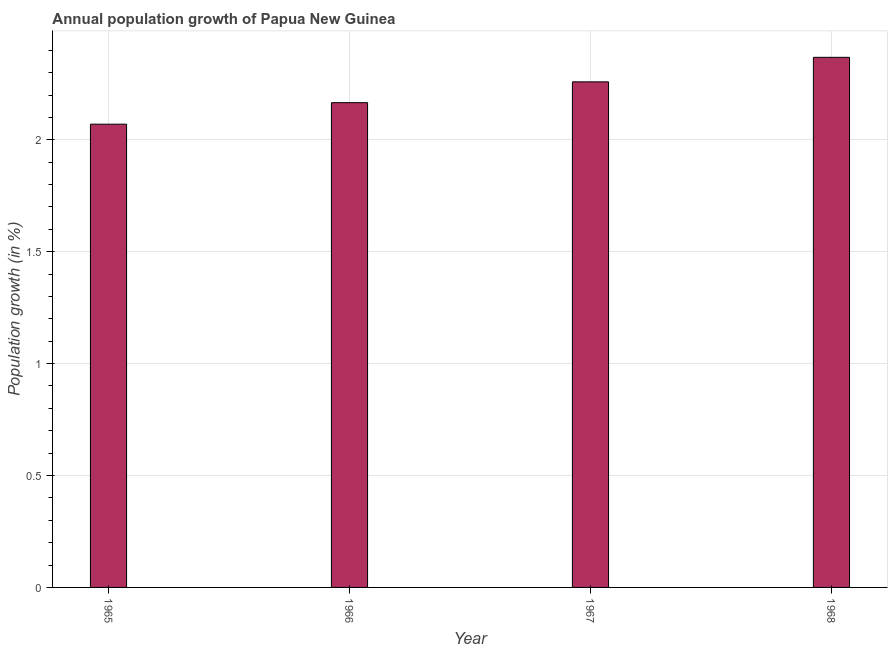Does the graph contain any zero values?
Provide a short and direct response. No. Does the graph contain grids?
Your answer should be very brief. Yes. What is the title of the graph?
Provide a succinct answer. Annual population growth of Papua New Guinea. What is the label or title of the Y-axis?
Offer a terse response. Population growth (in %). What is the population growth in 1968?
Provide a short and direct response. 2.37. Across all years, what is the maximum population growth?
Keep it short and to the point. 2.37. Across all years, what is the minimum population growth?
Ensure brevity in your answer.  2.07. In which year was the population growth maximum?
Provide a short and direct response. 1968. In which year was the population growth minimum?
Provide a succinct answer. 1965. What is the sum of the population growth?
Offer a terse response. 8.86. What is the difference between the population growth in 1965 and 1968?
Provide a short and direct response. -0.3. What is the average population growth per year?
Offer a very short reply. 2.22. What is the median population growth?
Make the answer very short. 2.21. Do a majority of the years between 1966 and 1968 (inclusive) have population growth greater than 2.1 %?
Your answer should be compact. Yes. What is the ratio of the population growth in 1967 to that in 1968?
Your answer should be very brief. 0.95. What is the difference between the highest and the second highest population growth?
Provide a succinct answer. 0.11. Is the sum of the population growth in 1967 and 1968 greater than the maximum population growth across all years?
Your answer should be very brief. Yes. What is the difference between the highest and the lowest population growth?
Keep it short and to the point. 0.3. In how many years, is the population growth greater than the average population growth taken over all years?
Offer a terse response. 2. How many bars are there?
Provide a short and direct response. 4. Are all the bars in the graph horizontal?
Offer a very short reply. No. How many years are there in the graph?
Your answer should be compact. 4. What is the difference between two consecutive major ticks on the Y-axis?
Make the answer very short. 0.5. What is the Population growth (in %) of 1965?
Offer a very short reply. 2.07. What is the Population growth (in %) in 1966?
Offer a very short reply. 2.17. What is the Population growth (in %) of 1967?
Offer a terse response. 2.26. What is the Population growth (in %) of 1968?
Offer a very short reply. 2.37. What is the difference between the Population growth (in %) in 1965 and 1966?
Your answer should be compact. -0.1. What is the difference between the Population growth (in %) in 1965 and 1967?
Provide a short and direct response. -0.19. What is the difference between the Population growth (in %) in 1965 and 1968?
Give a very brief answer. -0.3. What is the difference between the Population growth (in %) in 1966 and 1967?
Provide a short and direct response. -0.09. What is the difference between the Population growth (in %) in 1966 and 1968?
Provide a short and direct response. -0.2. What is the difference between the Population growth (in %) in 1967 and 1968?
Ensure brevity in your answer.  -0.11. What is the ratio of the Population growth (in %) in 1965 to that in 1966?
Offer a very short reply. 0.96. What is the ratio of the Population growth (in %) in 1965 to that in 1967?
Ensure brevity in your answer.  0.92. What is the ratio of the Population growth (in %) in 1965 to that in 1968?
Offer a very short reply. 0.87. What is the ratio of the Population growth (in %) in 1966 to that in 1967?
Ensure brevity in your answer.  0.96. What is the ratio of the Population growth (in %) in 1966 to that in 1968?
Your answer should be compact. 0.91. What is the ratio of the Population growth (in %) in 1967 to that in 1968?
Offer a very short reply. 0.95. 